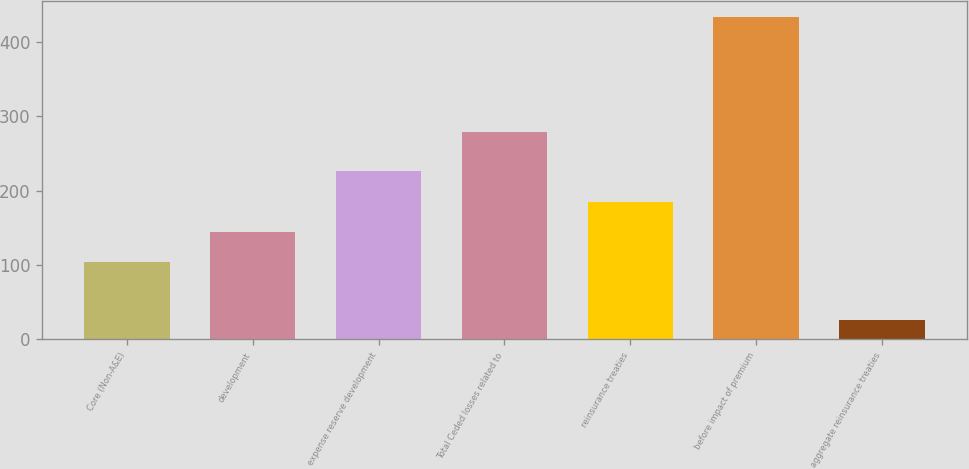Convert chart to OTSL. <chart><loc_0><loc_0><loc_500><loc_500><bar_chart><fcel>Core (Non-A&E)<fcel>development<fcel>expense reserve development<fcel>Total Ceded losses related to<fcel>reinsurance treaties<fcel>before impact of premium<fcel>aggregate reinsurance treaties<nl><fcel>104<fcel>144.7<fcel>226.1<fcel>279<fcel>185.4<fcel>433<fcel>26<nl></chart> 